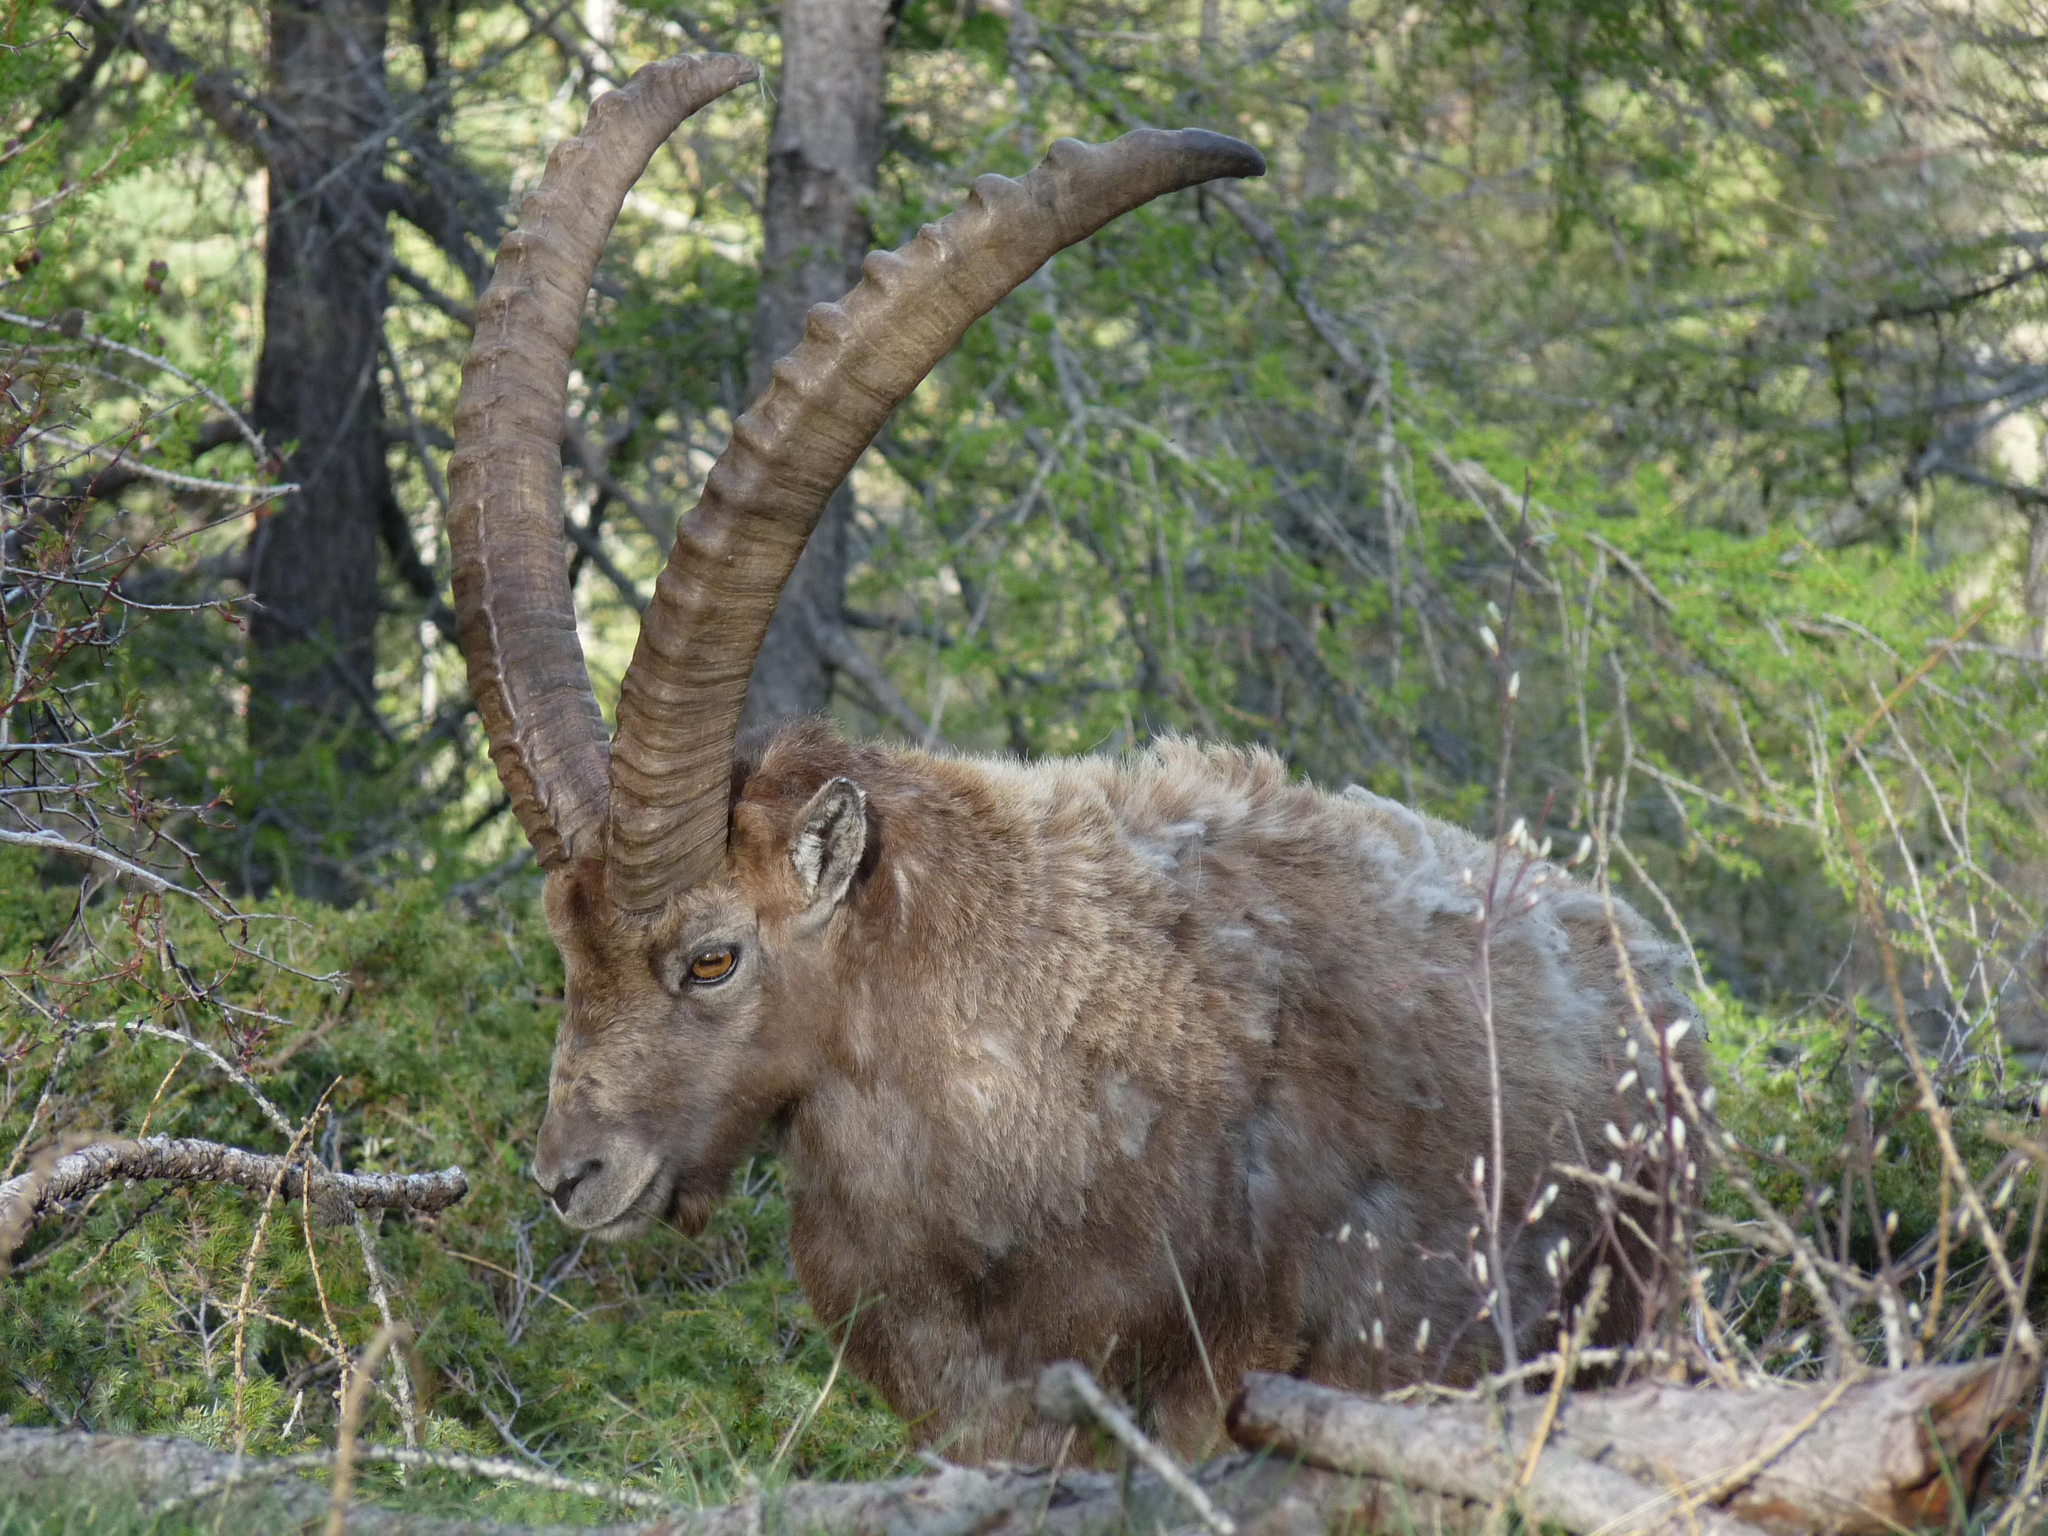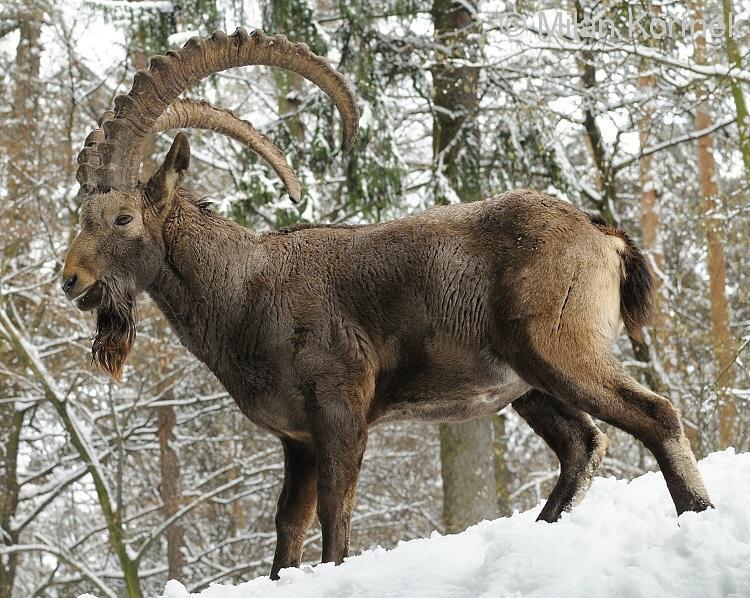The first image is the image on the left, the second image is the image on the right. Given the left and right images, does the statement "At least one image shows a horned animal resting on the ground with feet visible, tucked underneath." hold true? Answer yes or no. No. 